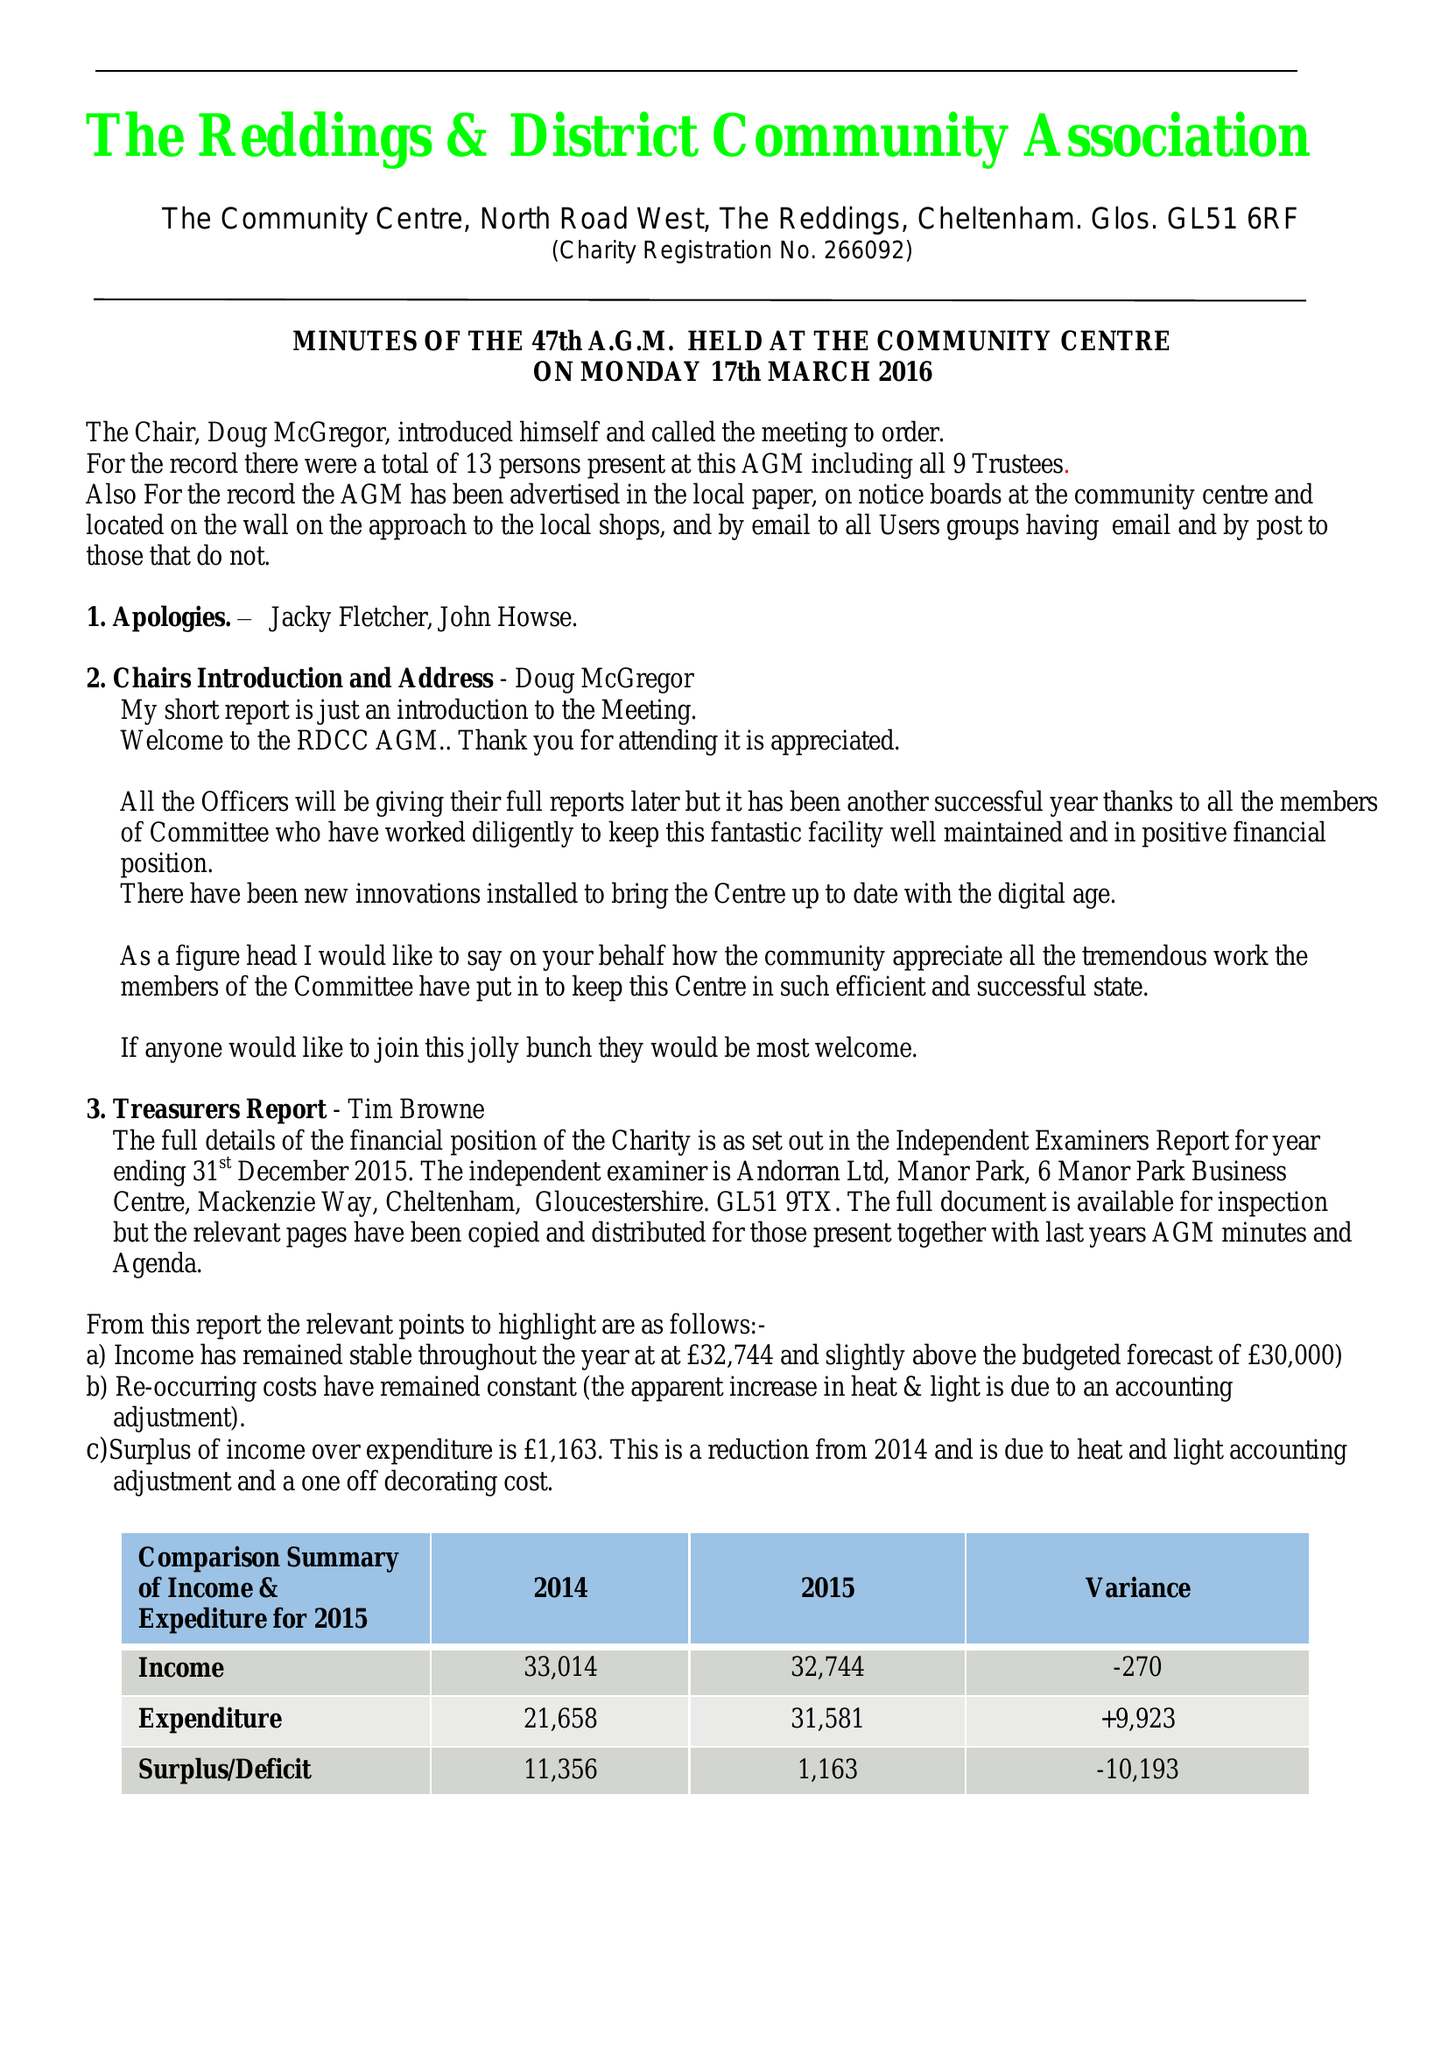What is the value for the address__street_line?
Answer the question using a single word or phrase. NORTH ROAD WEST 